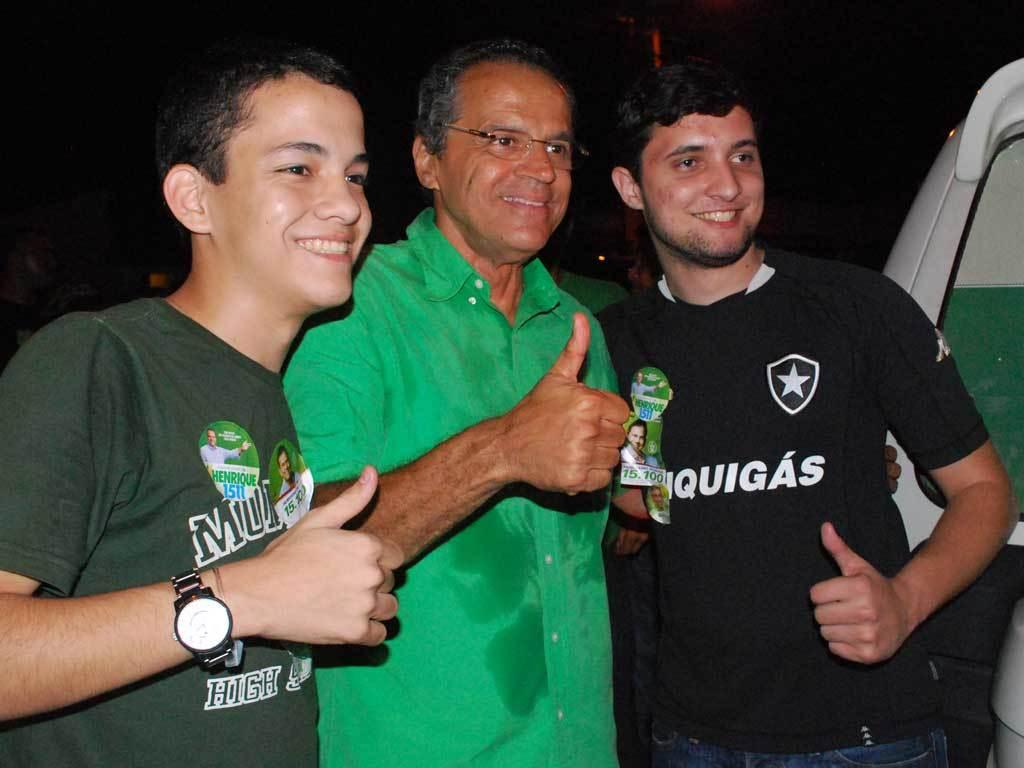How many men are present in the image? There are three men standing in the image. What can be observed about the background of the image? The background of the image is blurred. Are there any other people visible in the image besides the three men? Yes, there are people visible in the background. What is located on the right side of the image? There is a vehicle on the right side of the image. What type of soap is being used by the men in the image? There is no soap present in the image, as it features three men standing with a blurred background and a vehicle on the right side. 